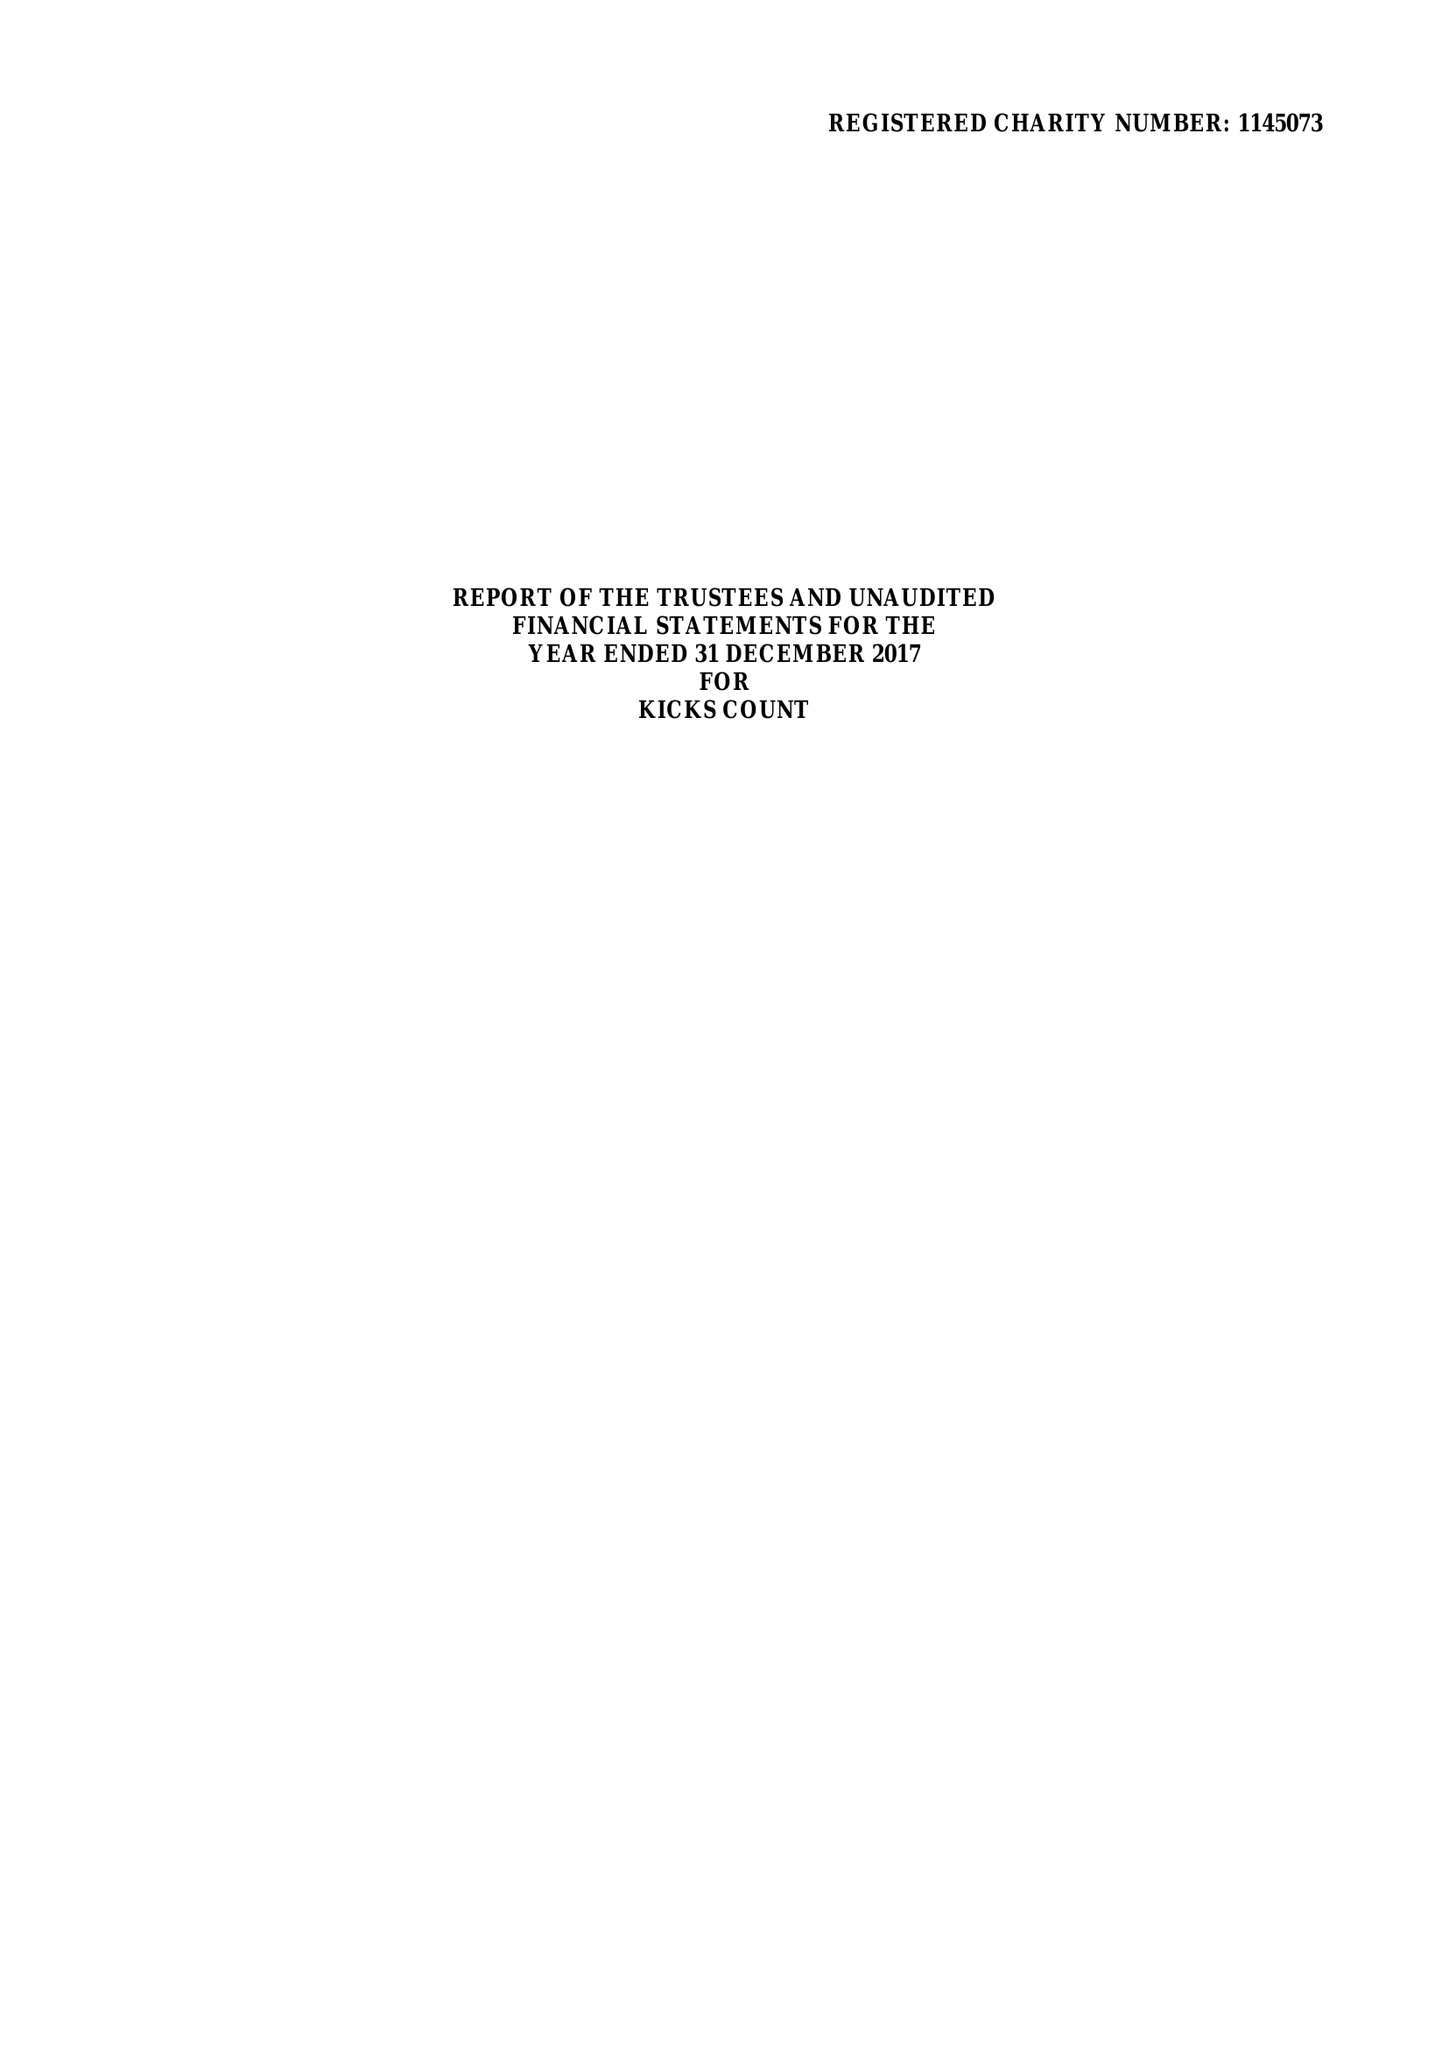What is the value for the address__postcode?
Answer the question using a single word or phrase. GU23 6BN 